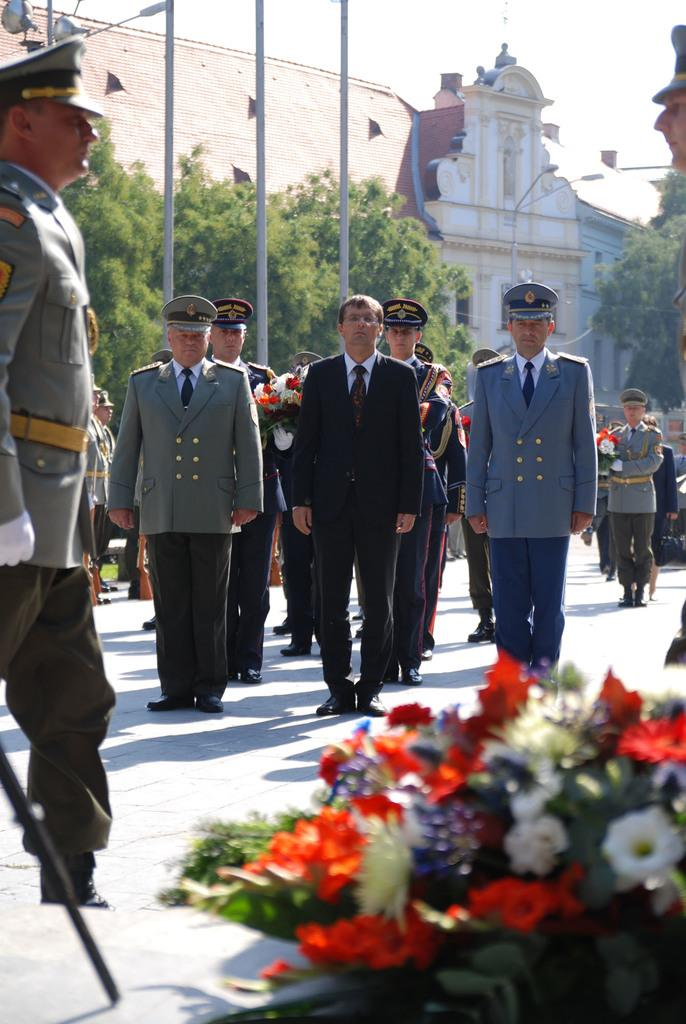Who or what is present in the image? There are people in the image. What are the people wearing? The people are wearing coats. What can be seen in the background of the image? There is a building in the background of the image. How would you describe the weather based on the image? The sky is clear, suggesting good weather. Can you find the receipt for the apparel in the image? There is no receipt visible in the image, and the apparel being worn is not the focus of the image. How many wings are visible on the people in the image? There are no wings visible on the people in the image; they are wearing coats. 